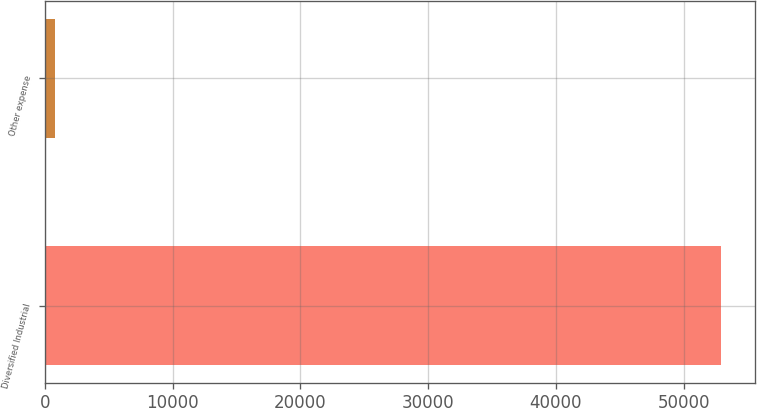<chart> <loc_0><loc_0><loc_500><loc_500><bar_chart><fcel>Diversified Industrial<fcel>Other expense<nl><fcel>52939<fcel>784<nl></chart> 